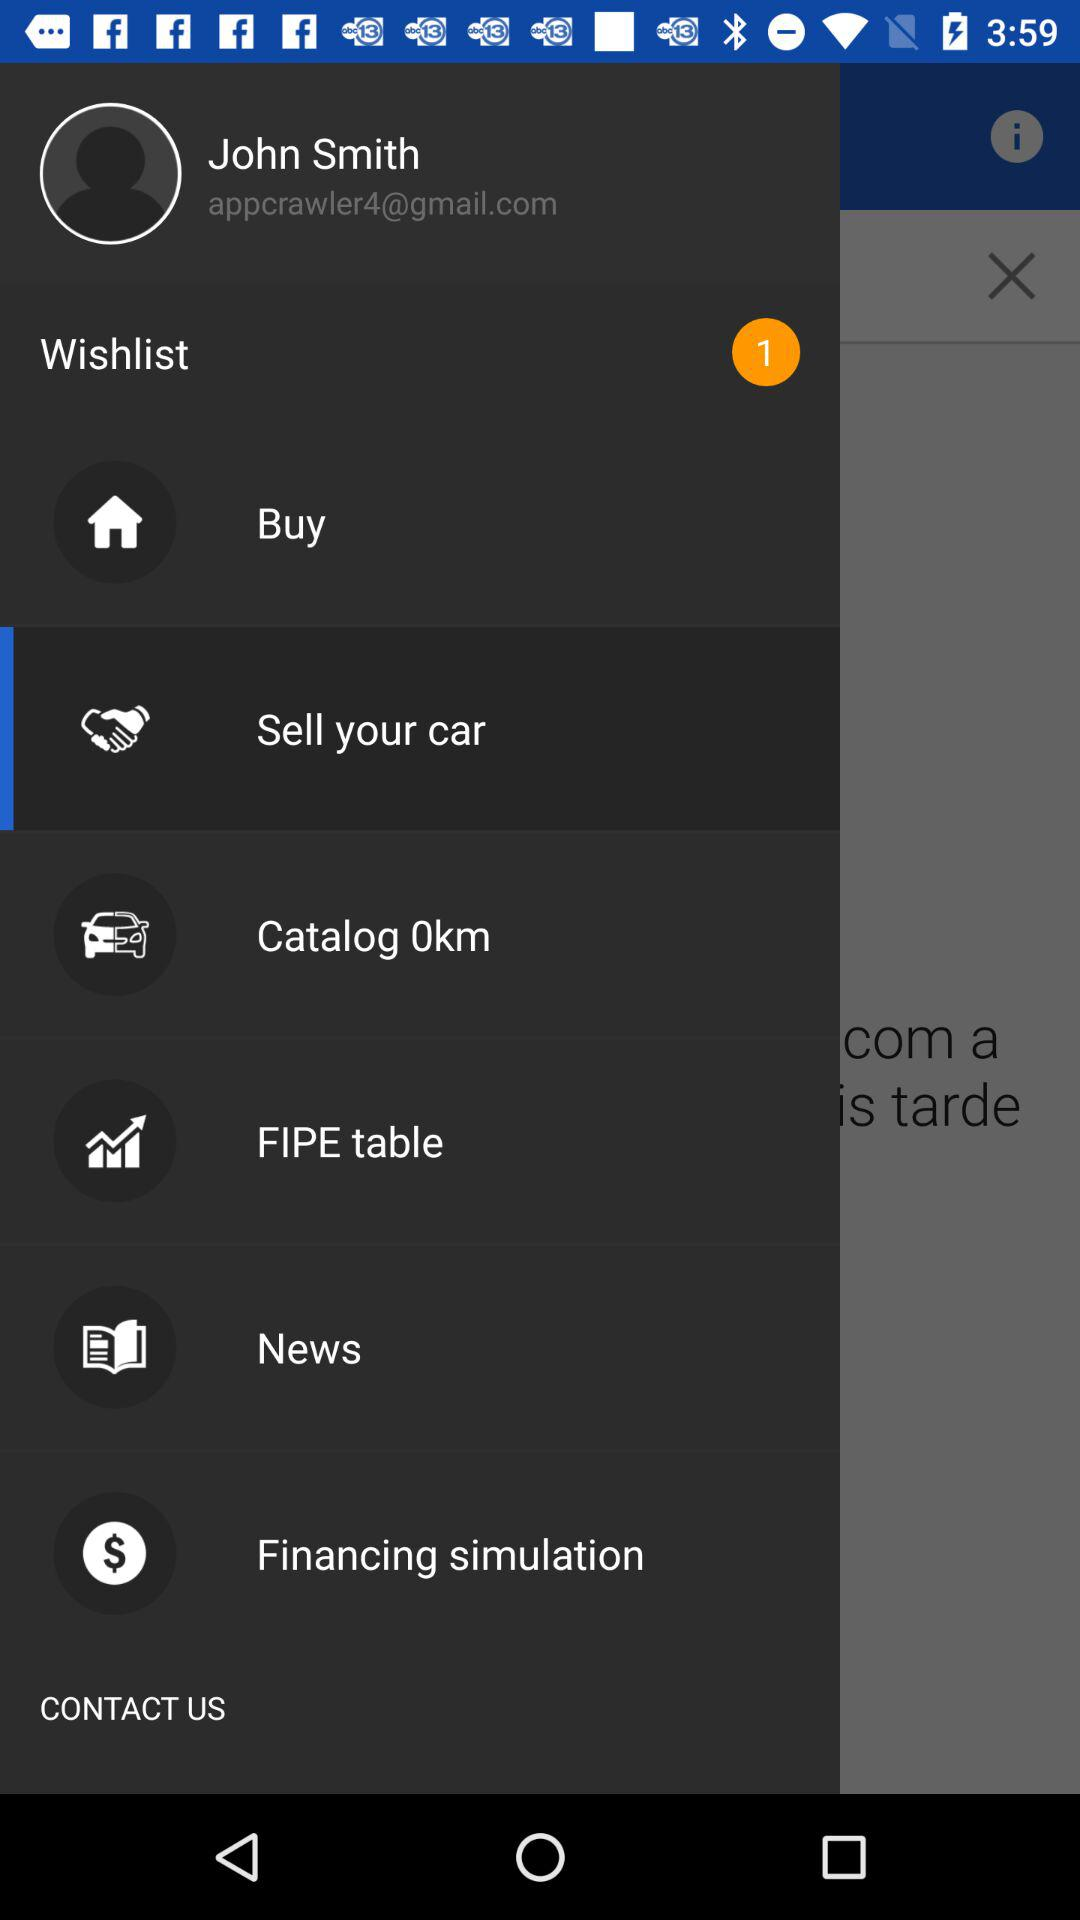What is the catalog distance?
When the provided information is insufficient, respond with <no answer>. <no answer> 